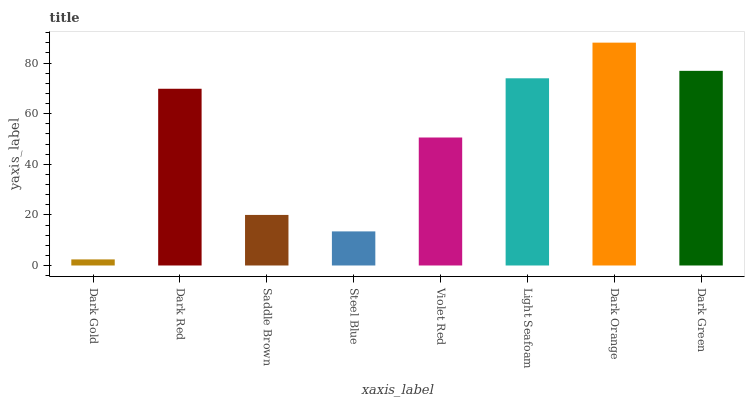Is Dark Gold the minimum?
Answer yes or no. Yes. Is Dark Orange the maximum?
Answer yes or no. Yes. Is Dark Red the minimum?
Answer yes or no. No. Is Dark Red the maximum?
Answer yes or no. No. Is Dark Red greater than Dark Gold?
Answer yes or no. Yes. Is Dark Gold less than Dark Red?
Answer yes or no. Yes. Is Dark Gold greater than Dark Red?
Answer yes or no. No. Is Dark Red less than Dark Gold?
Answer yes or no. No. Is Dark Red the high median?
Answer yes or no. Yes. Is Violet Red the low median?
Answer yes or no. Yes. Is Dark Gold the high median?
Answer yes or no. No. Is Light Seafoam the low median?
Answer yes or no. No. 